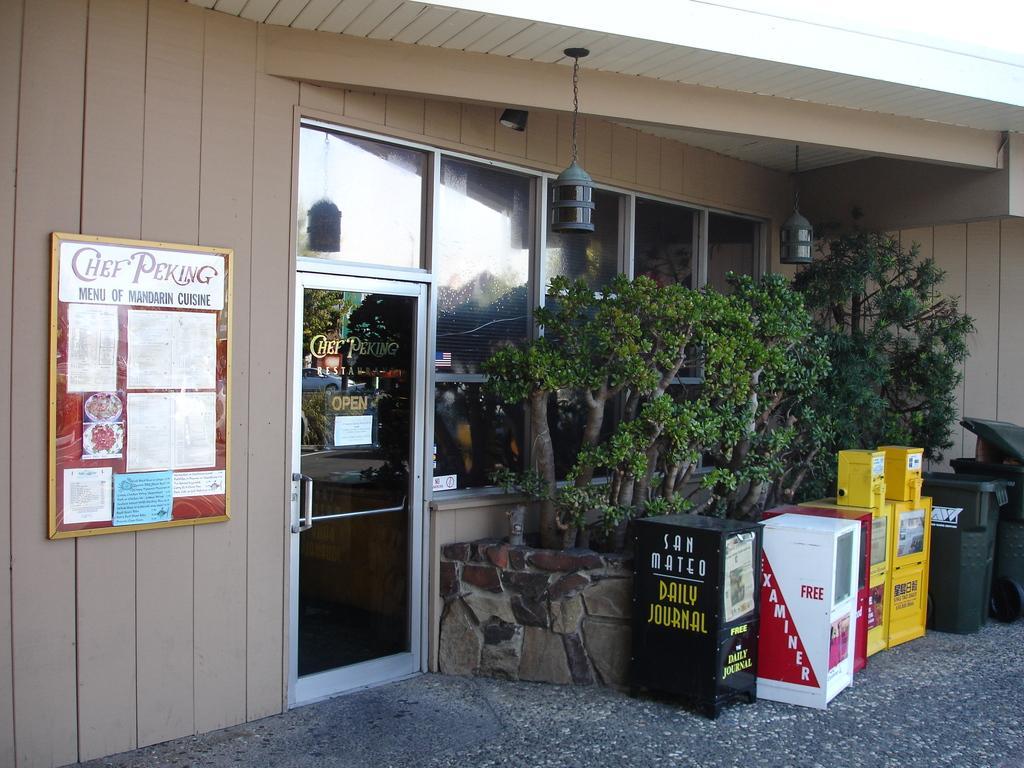In one or two sentences, can you explain what this image depicts? In this picture there is a building. In front of the door I can see some boxes. On the right I can see the dustbins, beside that I can see the plants which are placed near to the windows. At the top there is a light hanging from the roof. On the left there is a poster which is placed on the wooden wall. In the top right corner I can see the sky. 